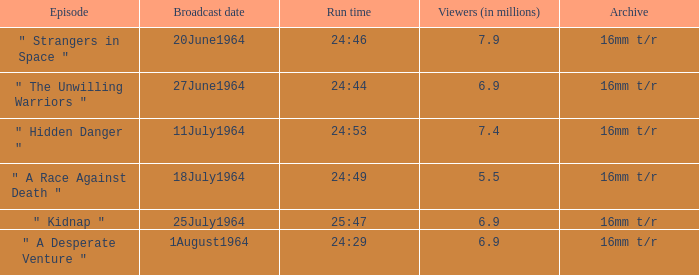4 million viewers? 24:53. Parse the full table. {'header': ['Episode', 'Broadcast date', 'Run time', 'Viewers (in millions)', 'Archive'], 'rows': [['" Strangers in Space "', '20June1964', '24:46', '7.9', '16mm t/r'], ['" The Unwilling Warriors "', '27June1964', '24:44', '6.9', '16mm t/r'], ['" Hidden Danger "', '11July1964', '24:53', '7.4', '16mm t/r'], ['" A Race Against Death "', '18July1964', '24:49', '5.5', '16mm t/r'], ['" Kidnap "', '25July1964', '25:47', '6.9', '16mm t/r'], ['" A Desperate Venture "', '1August1964', '24:29', '6.9', '16mm t/r']]} 